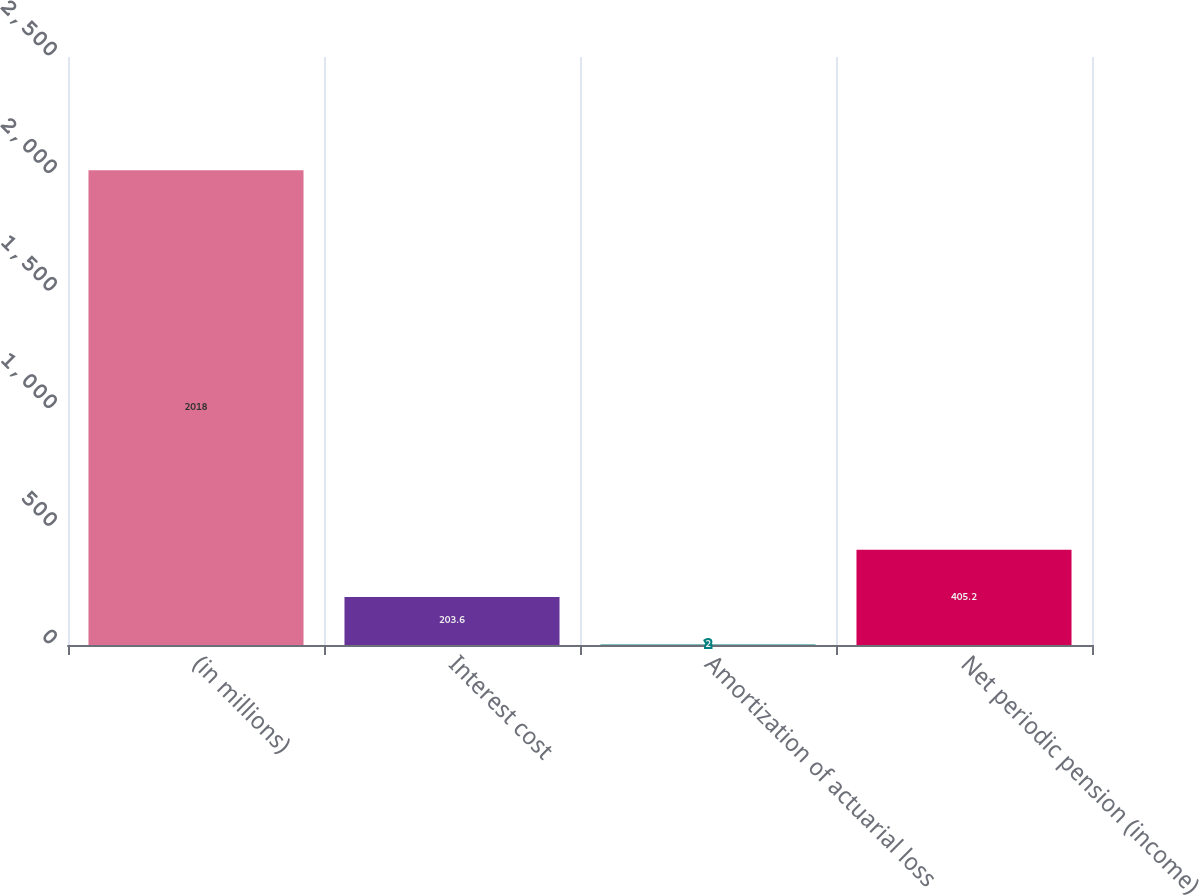Convert chart. <chart><loc_0><loc_0><loc_500><loc_500><bar_chart><fcel>(in millions)<fcel>Interest cost<fcel>Amortization of actuarial loss<fcel>Net periodic pension (income)<nl><fcel>2018<fcel>203.6<fcel>2<fcel>405.2<nl></chart> 